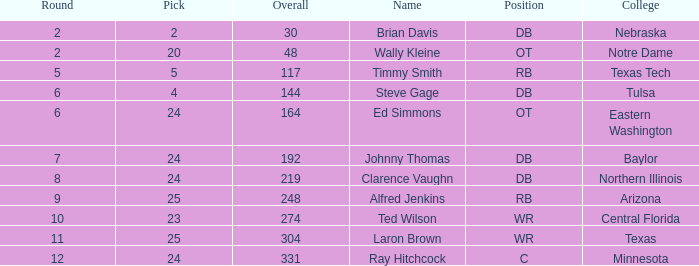Which upper circle has a selection less than 2? None. 